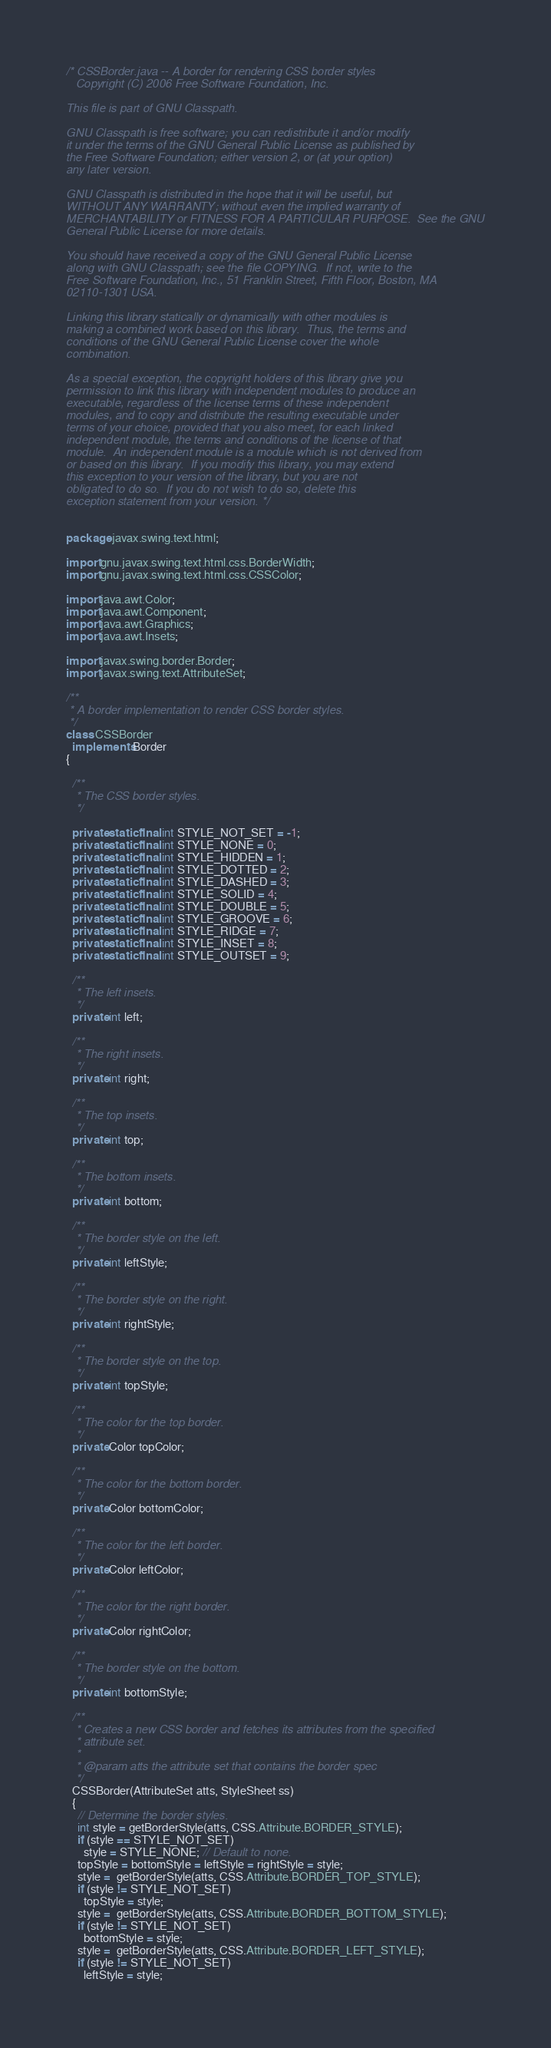Convert code to text. <code><loc_0><loc_0><loc_500><loc_500><_Java_>/* CSSBorder.java -- A border for rendering CSS border styles
   Copyright (C) 2006 Free Software Foundation, Inc.

This file is part of GNU Classpath.

GNU Classpath is free software; you can redistribute it and/or modify
it under the terms of the GNU General Public License as published by
the Free Software Foundation; either version 2, or (at your option)
any later version.

GNU Classpath is distributed in the hope that it will be useful, but
WITHOUT ANY WARRANTY; without even the implied warranty of
MERCHANTABILITY or FITNESS FOR A PARTICULAR PURPOSE.  See the GNU
General Public License for more details.

You should have received a copy of the GNU General Public License
along with GNU Classpath; see the file COPYING.  If not, write to the
Free Software Foundation, Inc., 51 Franklin Street, Fifth Floor, Boston, MA
02110-1301 USA.

Linking this library statically or dynamically with other modules is
making a combined work based on this library.  Thus, the terms and
conditions of the GNU General Public License cover the whole
combination.

As a special exception, the copyright holders of this library give you
permission to link this library with independent modules to produce an
executable, regardless of the license terms of these independent
modules, and to copy and distribute the resulting executable under
terms of your choice, provided that you also meet, for each linked
independent module, the terms and conditions of the license of that
module.  An independent module is a module which is not derived from
or based on this library.  If you modify this library, you may extend
this exception to your version of the library, but you are not
obligated to do so.  If you do not wish to do so, delete this
exception statement from your version. */


package javax.swing.text.html;

import gnu.javax.swing.text.html.css.BorderWidth;
import gnu.javax.swing.text.html.css.CSSColor;

import java.awt.Color;
import java.awt.Component;
import java.awt.Graphics;
import java.awt.Insets;

import javax.swing.border.Border;
import javax.swing.text.AttributeSet;

/**
 * A border implementation to render CSS border styles.
 */
class CSSBorder
  implements Border
{

  /**
   * The CSS border styles.
   */

  private static final int STYLE_NOT_SET = -1;
  private static final int STYLE_NONE = 0;
  private static final int STYLE_HIDDEN = 1;
  private static final int STYLE_DOTTED = 2;
  private static final int STYLE_DASHED = 3;
  private static final int STYLE_SOLID = 4;
  private static final int STYLE_DOUBLE = 5;
  private static final int STYLE_GROOVE = 6;
  private static final int STYLE_RIDGE = 7;
  private static final int STYLE_INSET = 8;
  private static final int STYLE_OUTSET = 9;

  /**
   * The left insets.
   */
  private int left;

  /**
   * The right insets.
   */
  private int right;

  /**
   * The top insets.
   */
  private int top;

  /**
   * The bottom insets.
   */
  private int bottom;

  /**
   * The border style on the left.
   */
  private int leftStyle;

  /**
   * The border style on the right.
   */
  private int rightStyle;

  /**
   * The border style on the top.
   */
  private int topStyle;

  /**
   * The color for the top border.
   */
  private Color topColor;

  /**
   * The color for the bottom border.
   */
  private Color bottomColor;

  /**
   * The color for the left border.
   */
  private Color leftColor;

  /**
   * The color for the right border.
   */
  private Color rightColor;

  /**
   * The border style on the bottom.
   */
  private int bottomStyle;

  /**
   * Creates a new CSS border and fetches its attributes from the specified
   * attribute set.
   *
   * @param atts the attribute set that contains the border spec
   */
  CSSBorder(AttributeSet atts, StyleSheet ss)
  {
    // Determine the border styles.
    int style = getBorderStyle(atts, CSS.Attribute.BORDER_STYLE);
    if (style == STYLE_NOT_SET)
      style = STYLE_NONE; // Default to none.
    topStyle = bottomStyle = leftStyle = rightStyle = style;
    style =  getBorderStyle(atts, CSS.Attribute.BORDER_TOP_STYLE);
    if (style != STYLE_NOT_SET)
      topStyle = style;
    style =  getBorderStyle(atts, CSS.Attribute.BORDER_BOTTOM_STYLE);
    if (style != STYLE_NOT_SET)
      bottomStyle = style;
    style =  getBorderStyle(atts, CSS.Attribute.BORDER_LEFT_STYLE);
    if (style != STYLE_NOT_SET)
      leftStyle = style;</code> 